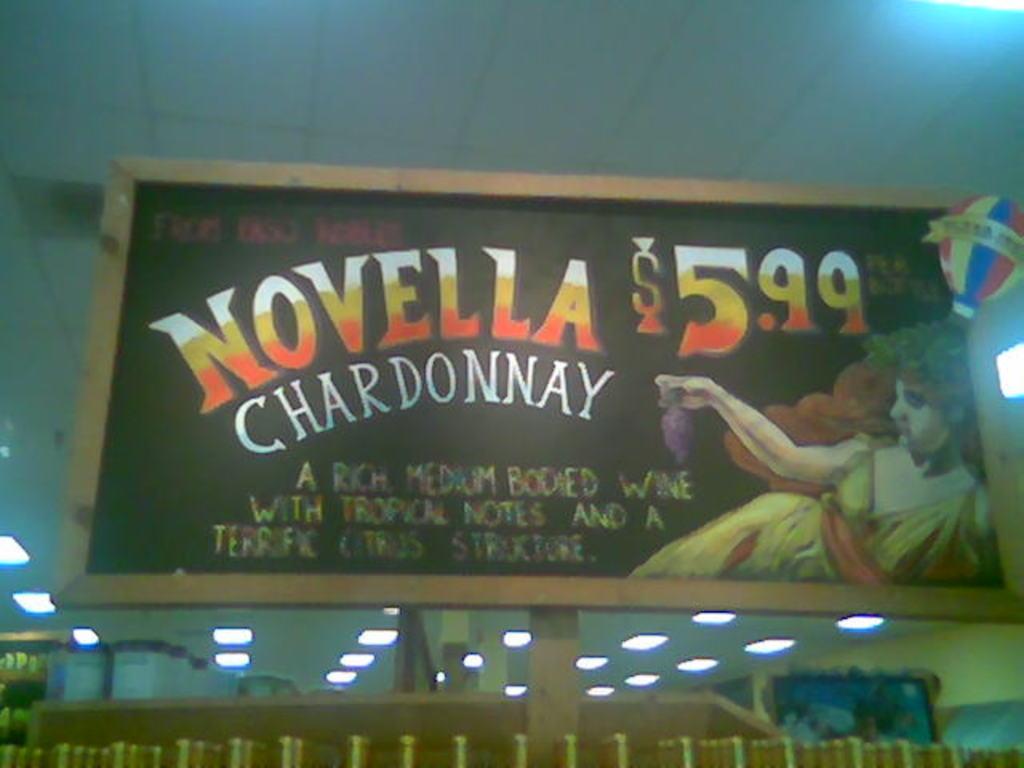How much is the chardonnay?
Your answer should be compact. 5.99. What type of alcohol is this?
Offer a very short reply. Chardonnay. 